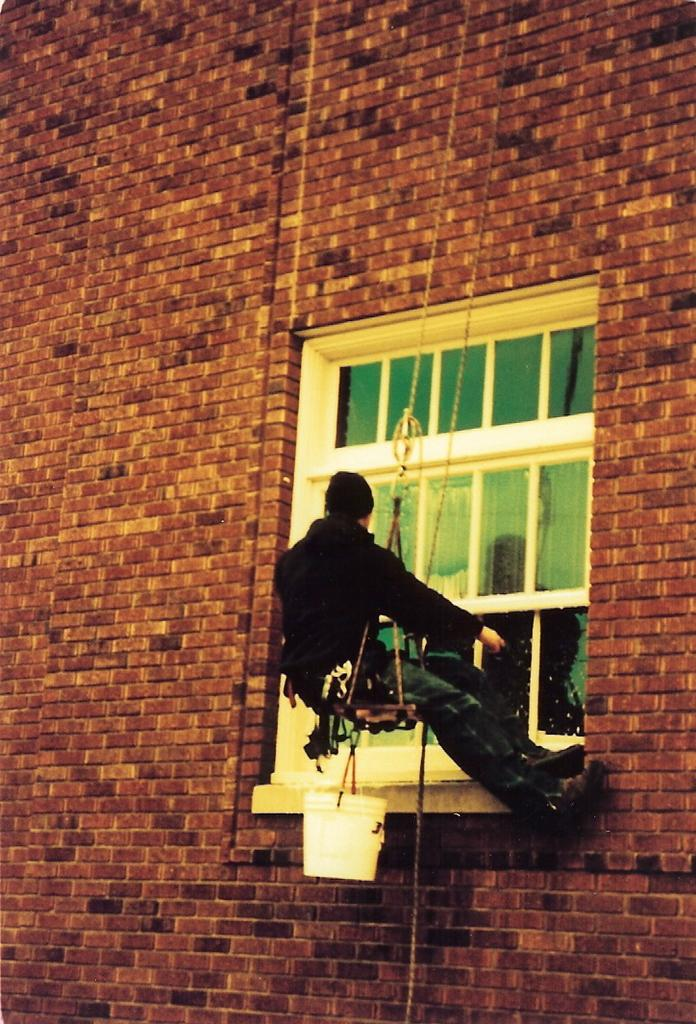What is the person in the image doing? The person is cleaning a glass window. What object might be used for holding cleaning solution in the image? There is a bucket in the image. What type of structure is visible in the image? There is a wall in the image. Is the person in the image afraid of the cart in the quicksand? There is no cart or quicksand present in the image, so the person cannot be afraid of them. 